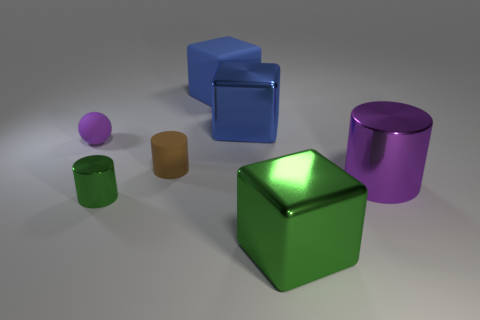Add 3 metallic blocks. How many objects exist? 10 Subtract all cylinders. How many objects are left? 4 Subtract 0 blue balls. How many objects are left? 7 Subtract all small purple spheres. Subtract all metal cylinders. How many objects are left? 4 Add 4 spheres. How many spheres are left? 5 Add 4 purple matte objects. How many purple matte objects exist? 5 